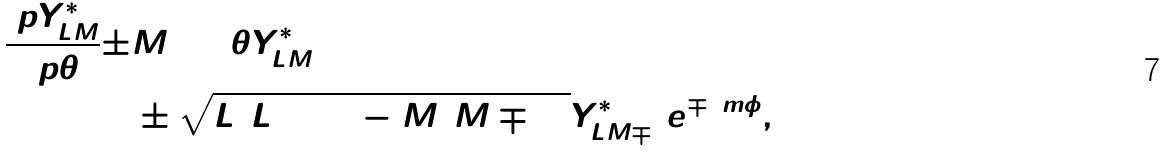Convert formula to latex. <formula><loc_0><loc_0><loc_500><loc_500>\frac { \ p Y _ { L M } ^ { * } } { \ p \theta } \pm & M \cot \theta Y _ { L M } ^ { * } = \\ & \pm \sqrt { L ( L + 1 ) - M ( M \mp 1 ) } Y _ { L M \mp 1 } ^ { * } e ^ { \mp \i m \phi } ,</formula> 